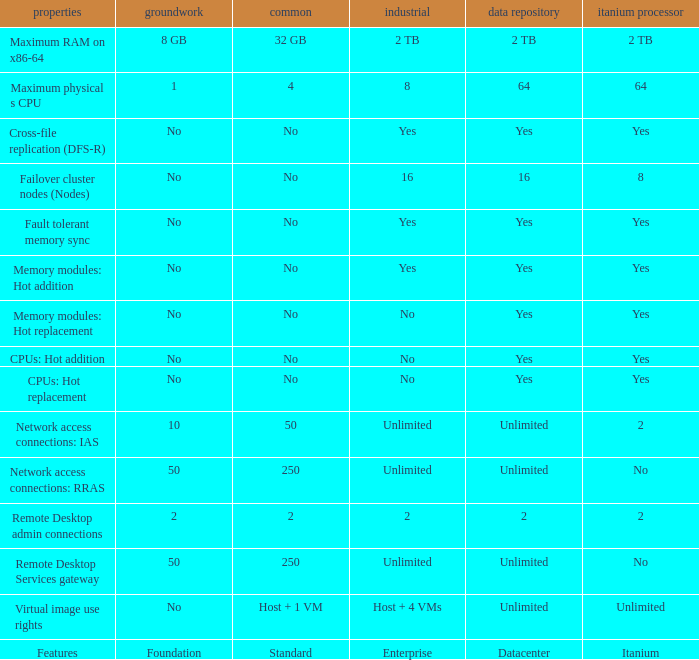Which Foundation has an Enterprise of 2? 2.0. 